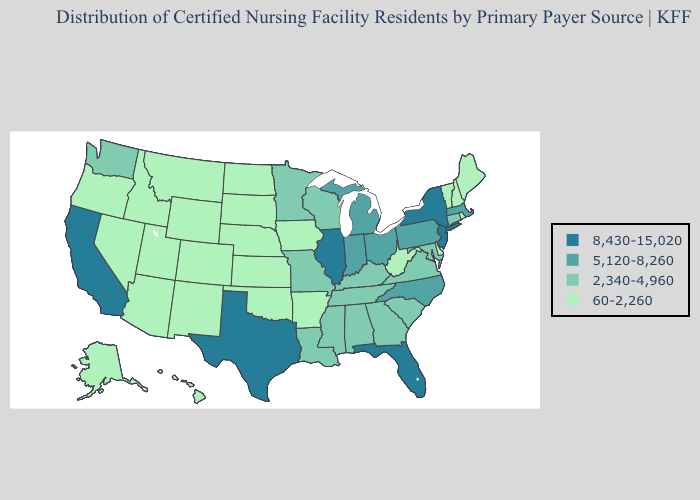Does the first symbol in the legend represent the smallest category?
Write a very short answer. No. What is the highest value in states that border Iowa?
Short answer required. 8,430-15,020. Among the states that border Pennsylvania , does West Virginia have the highest value?
Short answer required. No. What is the lowest value in the South?
Concise answer only. 60-2,260. What is the lowest value in states that border Massachusetts?
Answer briefly. 60-2,260. Does Texas have the highest value in the South?
Quick response, please. Yes. What is the lowest value in the USA?
Concise answer only. 60-2,260. What is the value of Washington?
Quick response, please. 2,340-4,960. Does Virginia have a higher value than Ohio?
Answer briefly. No. What is the value of Arkansas?
Concise answer only. 60-2,260. Name the states that have a value in the range 60-2,260?
Give a very brief answer. Alaska, Arizona, Arkansas, Colorado, Delaware, Hawaii, Idaho, Iowa, Kansas, Maine, Montana, Nebraska, Nevada, New Hampshire, New Mexico, North Dakota, Oklahoma, Oregon, Rhode Island, South Dakota, Utah, Vermont, West Virginia, Wyoming. What is the value of Massachusetts?
Quick response, please. 5,120-8,260. Name the states that have a value in the range 60-2,260?
Be succinct. Alaska, Arizona, Arkansas, Colorado, Delaware, Hawaii, Idaho, Iowa, Kansas, Maine, Montana, Nebraska, Nevada, New Hampshire, New Mexico, North Dakota, Oklahoma, Oregon, Rhode Island, South Dakota, Utah, Vermont, West Virginia, Wyoming. Which states have the lowest value in the MidWest?
Quick response, please. Iowa, Kansas, Nebraska, North Dakota, South Dakota. Name the states that have a value in the range 2,340-4,960?
Keep it brief. Alabama, Connecticut, Georgia, Kentucky, Louisiana, Maryland, Minnesota, Mississippi, Missouri, South Carolina, Tennessee, Virginia, Washington, Wisconsin. 